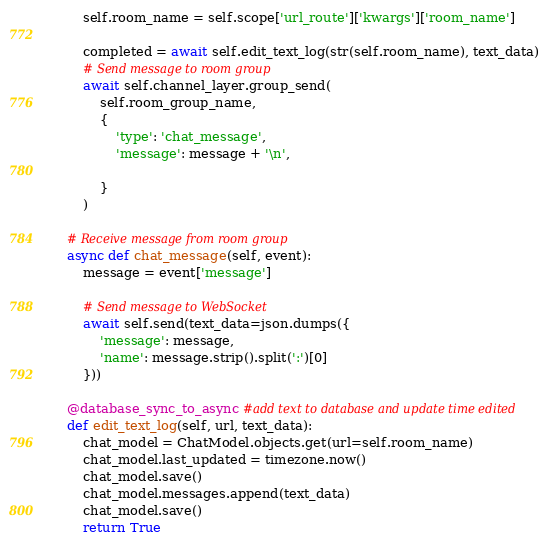Convert code to text. <code><loc_0><loc_0><loc_500><loc_500><_Python_>        self.room_name = self.scope['url_route']['kwargs']['room_name']

        completed = await self.edit_text_log(str(self.room_name), text_data)
        # Send message to room group
        await self.channel_layer.group_send(
            self.room_group_name,
            {
                'type': 'chat_message',
                'message': message + '\n',
                
            }
        )

    # Receive message from room group
    async def chat_message(self, event):
        message = event['message']
        
        # Send message to WebSocket
        await self.send(text_data=json.dumps({
            'message': message,
            'name': message.strip().split(':')[0]
        }))

    @database_sync_to_async #add text to database and update time edited
    def edit_text_log(self, url, text_data):
        chat_model = ChatModel.objects.get(url=self.room_name)
        chat_model.last_updated = timezone.now()
        chat_model.save()
        chat_model.messages.append(text_data)
        chat_model.save()
        return True
</code> 